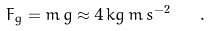<formula> <loc_0><loc_0><loc_500><loc_500>F _ { g } = m \, g \approx 4 \, k g \, m \, s ^ { - 2 } \quad .</formula> 